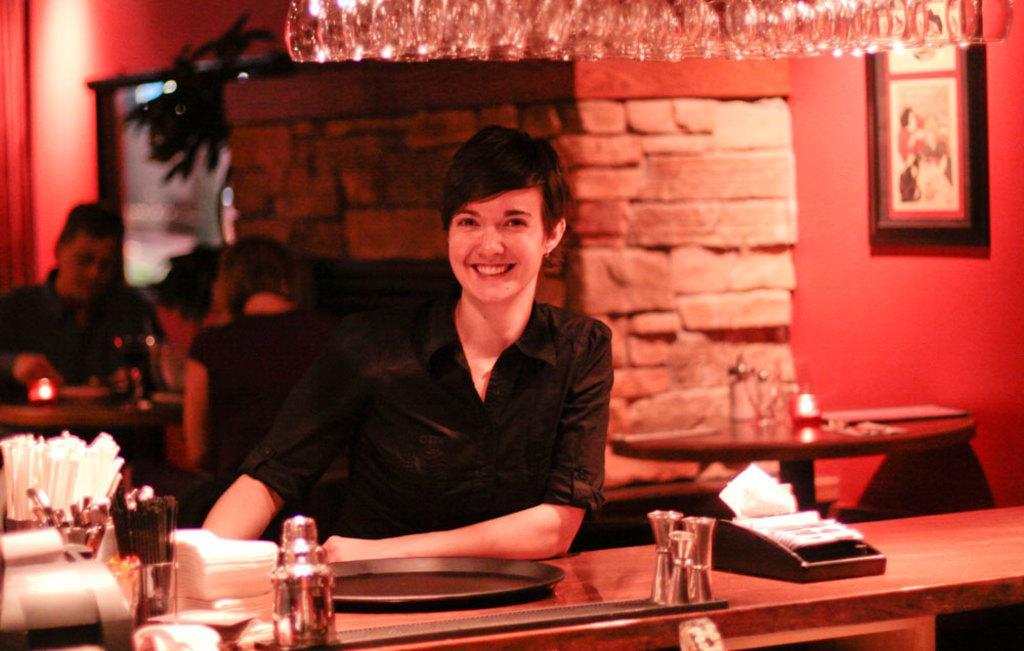Could you give a brief overview of what you see in this image? In this image, we can see a woman is smiling and seeing. She kept her hand on the wooden table. Here we can see so many things are placed on the table. Background there is a pillar, wall, photo frame. Here we can see few people, table, some objects. Top of the image, we can see glasses. 